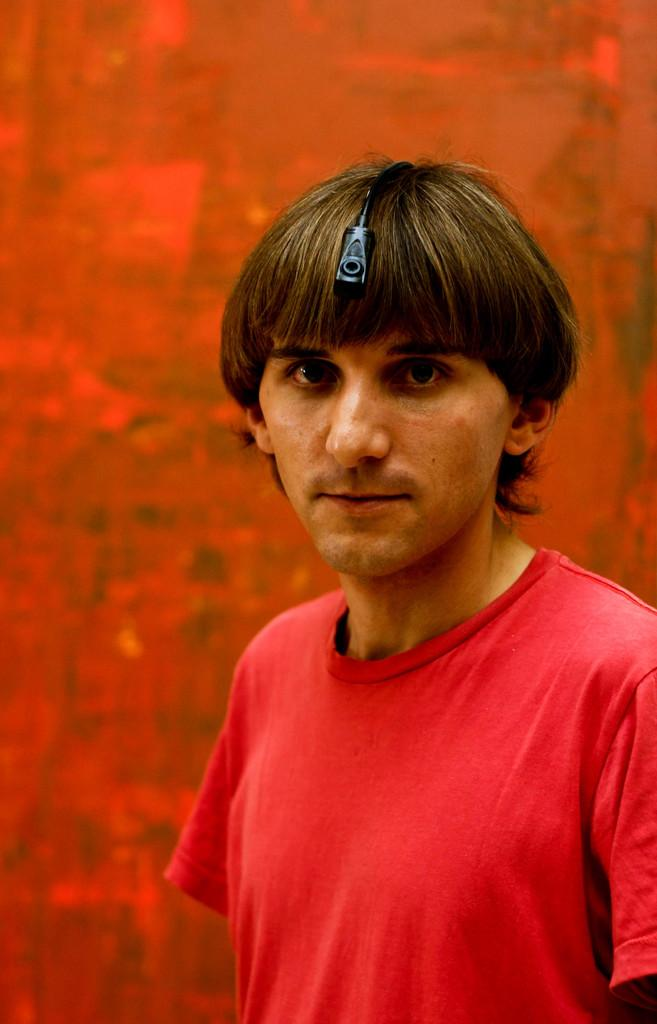Who is the main subject in the image? There is a man in the image. What is the man wearing? The man is wearing a red t-shirt. What direction is the man looking in? The man is looking forward. What color is the background of the image? The background of the image is red. What type of plate is being used to stamp the man's forehead in the image? There is no plate or stamping activity present in the image. 